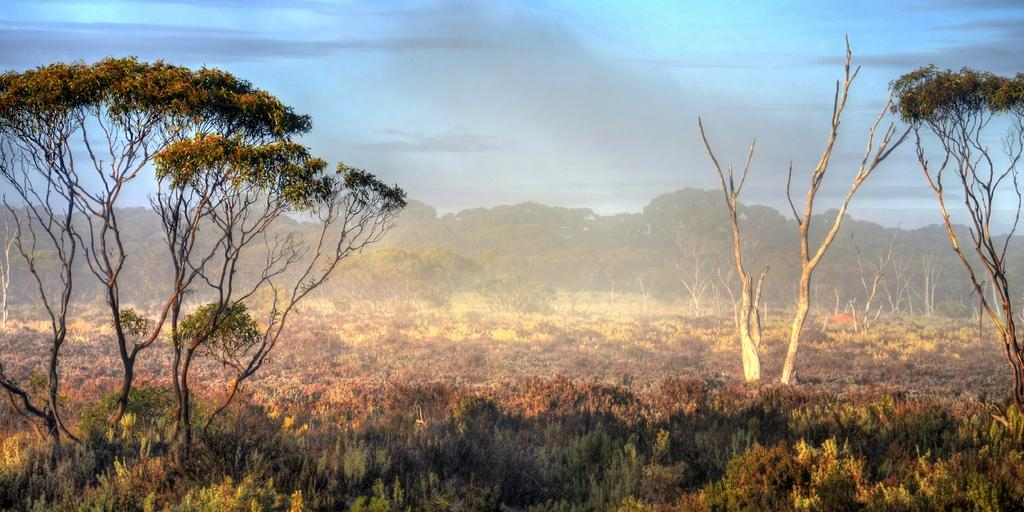What type of environment is shown in the image? The image depicts a forest. What are the main features of the forest? There are trees in the image. What can be seen in the sky in the image? The sky is visible at the top of the image, and there are clouds in the sky. What is present at the bottom of the image? Plants are present at the bottom of the image. What color is the crayon used to draw the forest in the image? There is no crayon present in the image; it is a photograph or digital representation of a forest. How does the toothpaste contribute to the appearance of the forest in the image? There is no toothpaste present in the image, and it does not contribute to the appearance of the forest. 